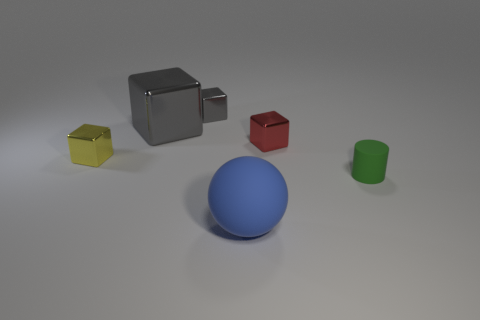Subtract all yellow cylinders. Subtract all brown cubes. How many cylinders are left? 1 Add 3 tiny yellow rubber cylinders. How many objects exist? 9 Subtract all balls. How many objects are left? 5 Subtract 0 cyan cubes. How many objects are left? 6 Subtract all tiny yellow metallic things. Subtract all big blue rubber spheres. How many objects are left? 4 Add 3 matte things. How many matte things are left? 5 Add 6 tiny cubes. How many tiny cubes exist? 9 